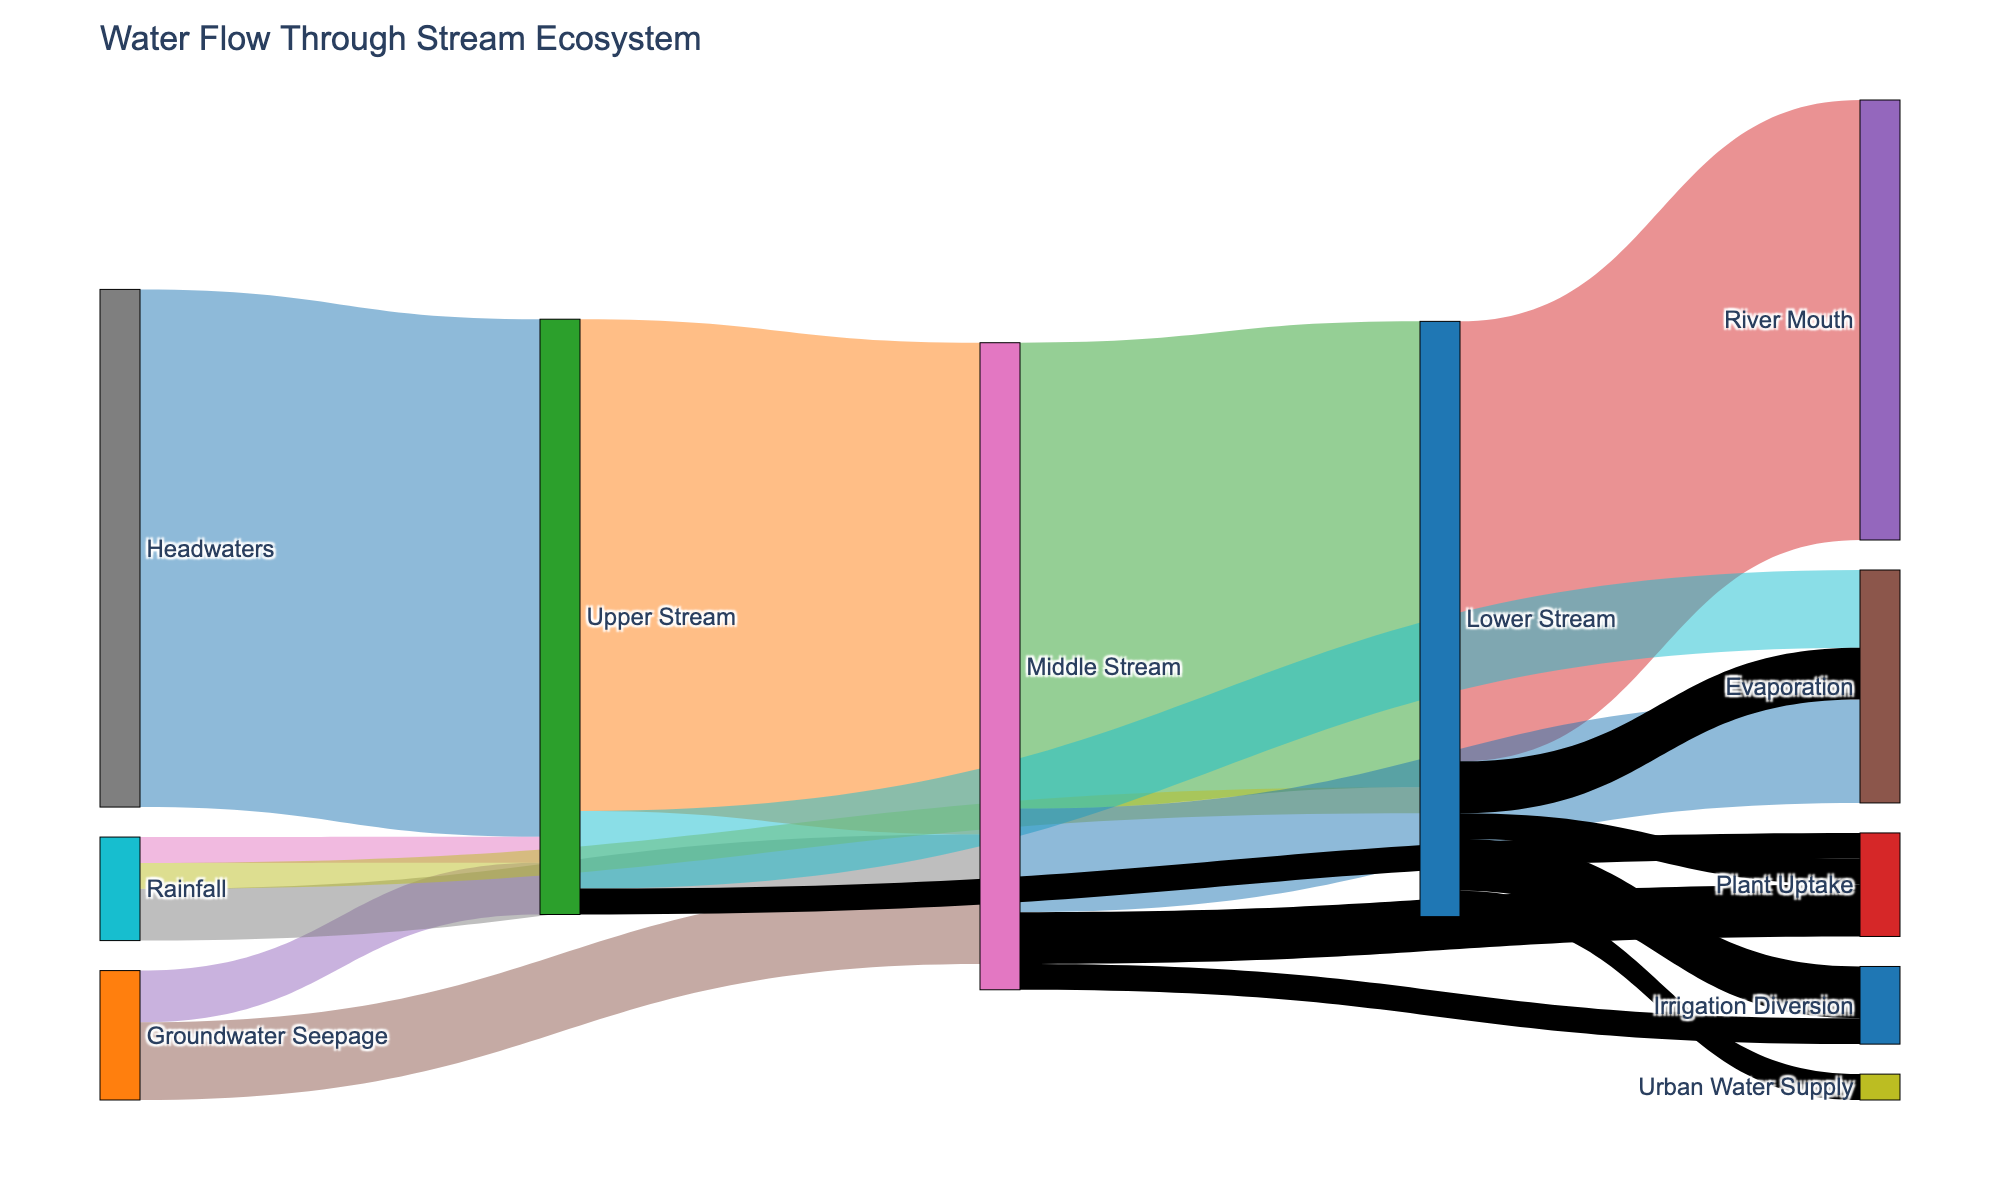What's the title of the figure? The title is found at the top of the figure and gives an overview of what the figure is about.
Answer: Water Flow Through Stream Ecosystem Which stage does "Headwaters" flow into? To find this, look for the link originating from "Headwaters" in the Sankey diagram and trace it to its next stage.
Answer: Upper Stream By how much does the water volume decrease from the "Upper Stream" to the "Lower Stream"? Subtract the value of water flowing into the Lower Stream (90) from the amount flowing into the Upper Stream (100 + 10 + 5 = 115), and subtract any outflows from the Upper Stream (15 + 5). Therefore, the decrease is (115 - 100).
Answer: 15 What are all the sources feeding into the "Middle Stream"? Identify all the links that target the "Middle Stream" and check their origins. These are "Upper Stream," "Groundwater Seepage," and "Rainfall."
Answer: Upper Stream, Groundwater Seepage, Rainfall Compare the amount of water lost to evaporation in the "Upper Stream" and the "Middle Stream." Which one is greater and by how much? Find the values of water lost to evaporation in both stages: 15 for Upper Stream and 20 for Middle Stream. Subtract the smaller value from the larger one, which is (20 - 15).
Answer: Middle Stream by 5 How much total water is contributed by "Groundwater Seepage" across all streams? Sum the values of water from "Groundwater Seepage" to all targets. The values are 10 (to Upper Stream) and 15 (to Middle Stream). Add (10 + 15).
Answer: 25 What is the total amount of water flowing out of the "Lower Stream"? Sum all the values flowing out of the Lower Stream. These are "River Mouth" (85), "Evaporation" (10), "Plant Uptake" (5), "Irrigation Diversion" (10), and "Urban Water Supply" (5). Add (85 + 10 + 5 + 10 + 5).
Answer: 115 How does the quantity of water flowing from "Rainfall" compare to that from "Groundwater Seepage" in the "Lower Stream"? Compare the values of water contributed by "Rainfall" (5) and "Groundwater Seepage" (0) to the Lower Stream.
Answer: Rainfall is greater by 5 Through which stage does the majority of water flow as it moves towards the "River Mouth"? Trace which stage directly leads the largest volume to the River Mouth. "Lower Stream" flows 85 units directly to the River Mouth, making it the stage with the majority flow towards it.
Answer: Lower Stream Calculate the net water entering the "Middle Stream" after accounting for all inflows and outflows. Sum all inflows: 95 (Upper Stream) + 15 (Groundwater Seepage) + 10 (Rainfall) = 120. Then, subtract all outflows: 90 (Lower Stream) + 20 (Evaporation) + 10 (Plant Uptake) + 5 (Irrigation Diversion) = 125. Net inflow is (120 - 125).
Answer: -5 